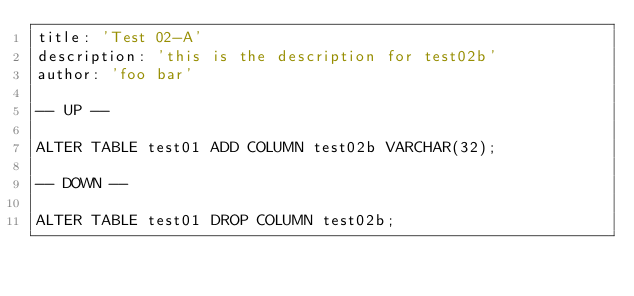<code> <loc_0><loc_0><loc_500><loc_500><_SQL_>title: 'Test 02-A'
description: 'this is the description for test02b'
author: 'foo bar'

-- UP --

ALTER TABLE test01 ADD COLUMN test02b VARCHAR(32);

-- DOWN --

ALTER TABLE test01 DROP COLUMN test02b;
</code> 